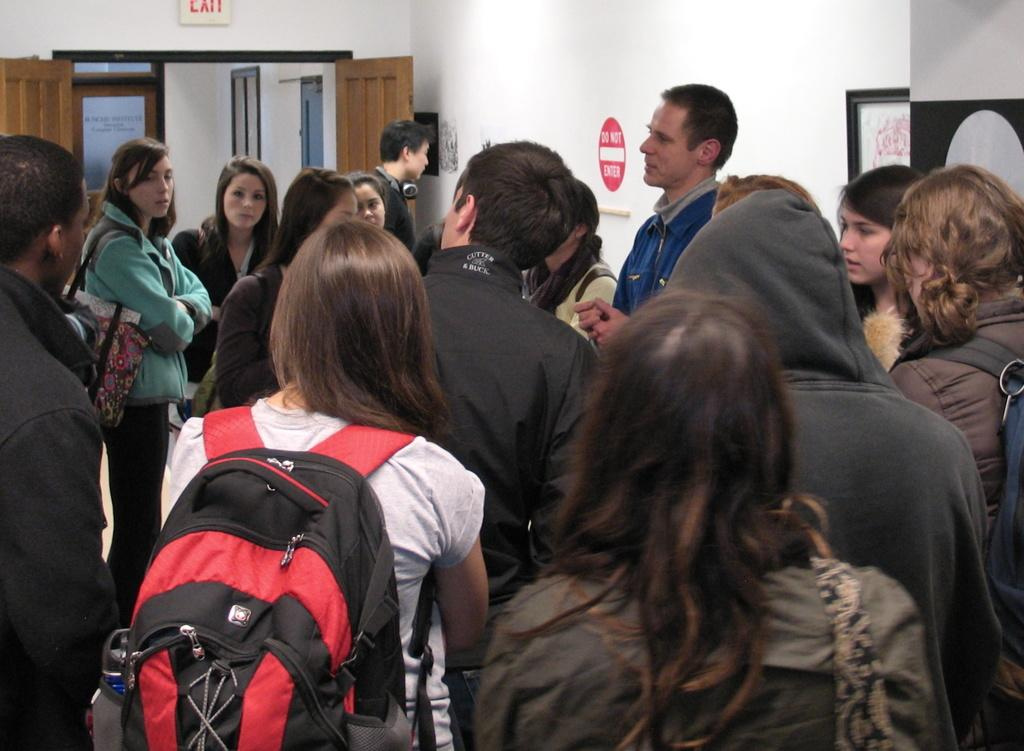Where is the setting of the image? The image is inside a room. Who or what can be seen in the image? There is a group of people in the image. What is one feature of the room that can be seen in the image? There is a door visible in the image. What decorative elements are present on the walls in the image? There are frames on the wall in the image. What type of spark can be seen coming from the sofa in the image? There is no sofa present in the image, so no spark can be seen coming from it. 